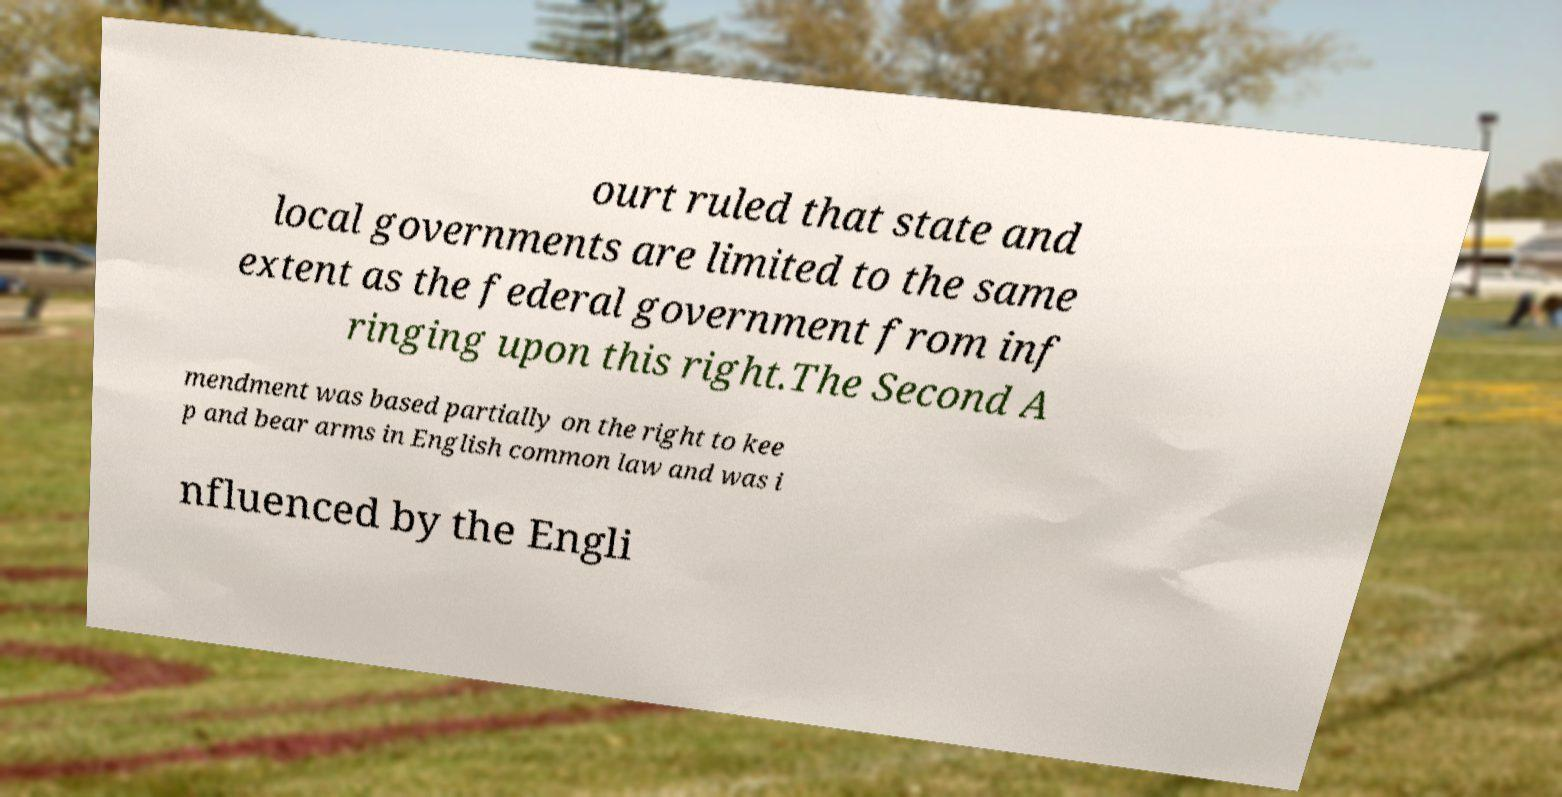Could you assist in decoding the text presented in this image and type it out clearly? ourt ruled that state and local governments are limited to the same extent as the federal government from inf ringing upon this right.The Second A mendment was based partially on the right to kee p and bear arms in English common law and was i nfluenced by the Engli 